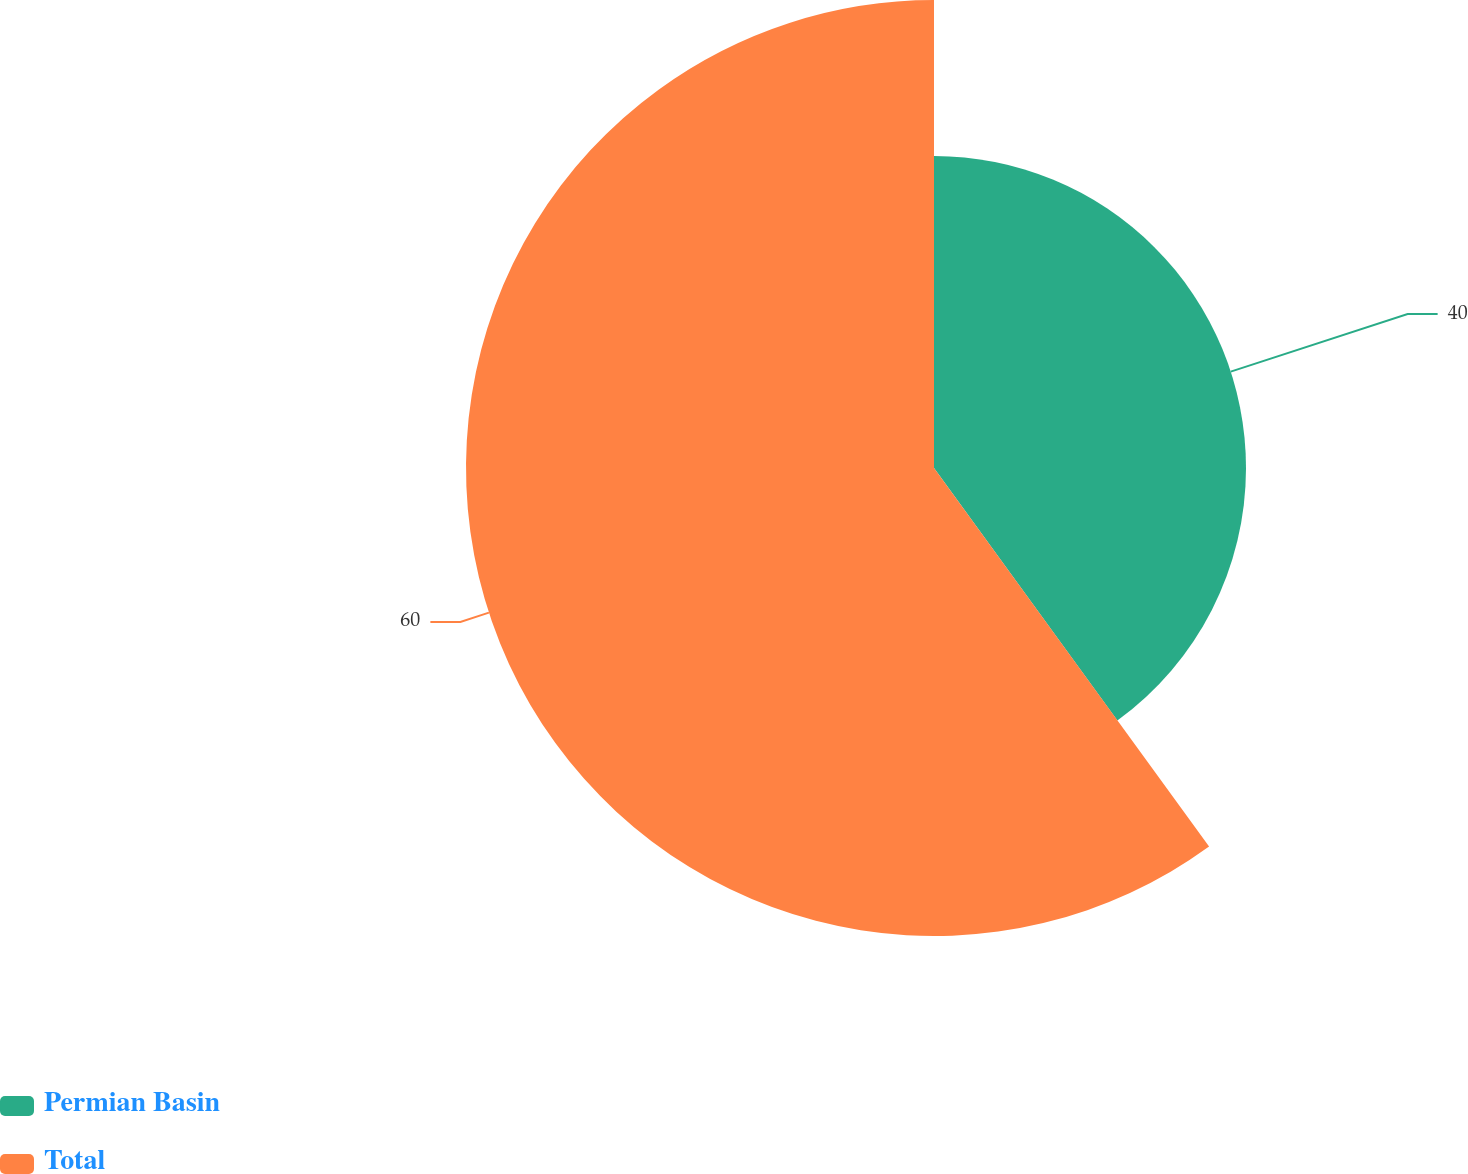<chart> <loc_0><loc_0><loc_500><loc_500><pie_chart><fcel>Permian Basin<fcel>Total<nl><fcel>40.0%<fcel>60.0%<nl></chart> 